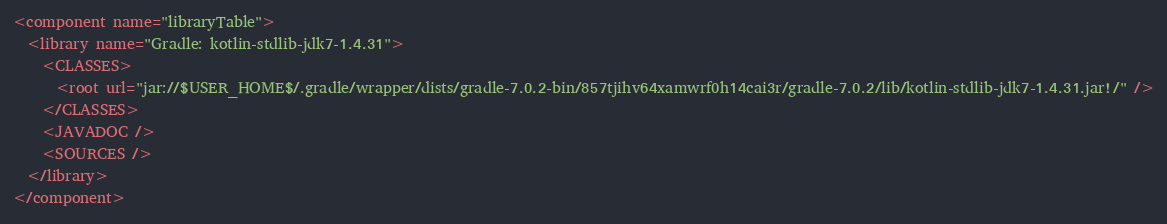<code> <loc_0><loc_0><loc_500><loc_500><_XML_><component name="libraryTable">
  <library name="Gradle: kotlin-stdlib-jdk7-1.4.31">
    <CLASSES>
      <root url="jar://$USER_HOME$/.gradle/wrapper/dists/gradle-7.0.2-bin/857tjihv64xamwrf0h14cai3r/gradle-7.0.2/lib/kotlin-stdlib-jdk7-1.4.31.jar!/" />
    </CLASSES>
    <JAVADOC />
    <SOURCES />
  </library>
</component></code> 